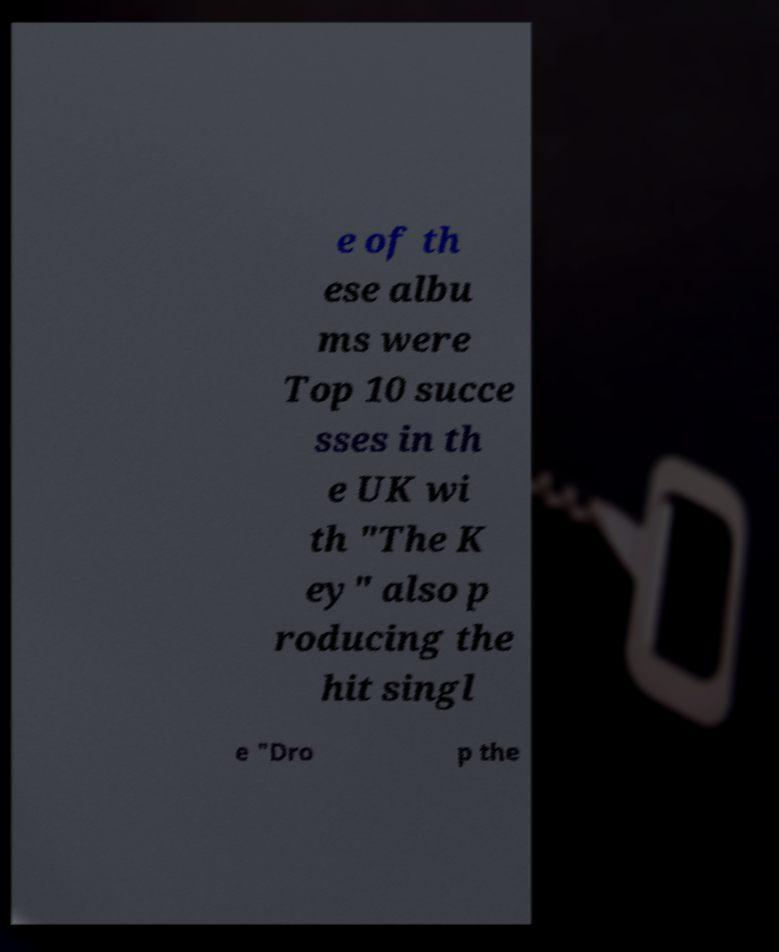Please identify and transcribe the text found in this image. e of th ese albu ms were Top 10 succe sses in th e UK wi th "The K ey" also p roducing the hit singl e "Dro p the 